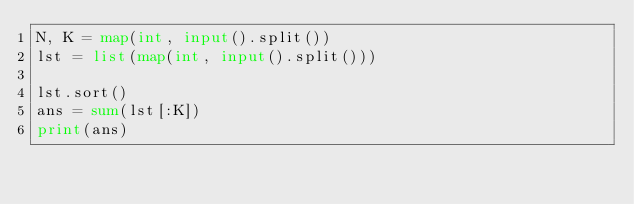Convert code to text. <code><loc_0><loc_0><loc_500><loc_500><_Python_>N, K = map(int, input().split())
lst = list(map(int, input().split()))

lst.sort()
ans = sum(lst[:K])
print(ans)</code> 